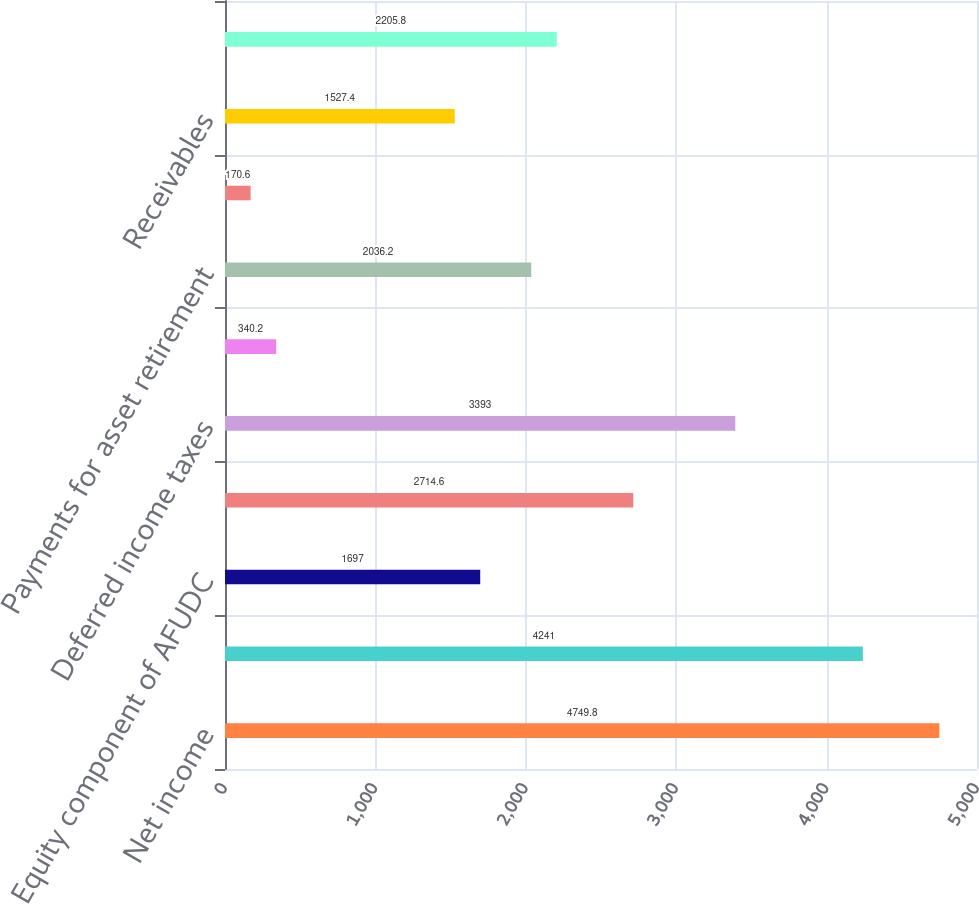<chart> <loc_0><loc_0><loc_500><loc_500><bar_chart><fcel>Net income<fcel>Depreciation amortization and<fcel>Equity component of AFUDC<fcel>Impairment charges<fcel>Deferred income taxes<fcel>Accrued pension and other<fcel>Payments for asset retirement<fcel>Net realized and unrealized<fcel>Receivables<fcel>Inventory<nl><fcel>4749.8<fcel>4241<fcel>1697<fcel>2714.6<fcel>3393<fcel>340.2<fcel>2036.2<fcel>170.6<fcel>1527.4<fcel>2205.8<nl></chart> 